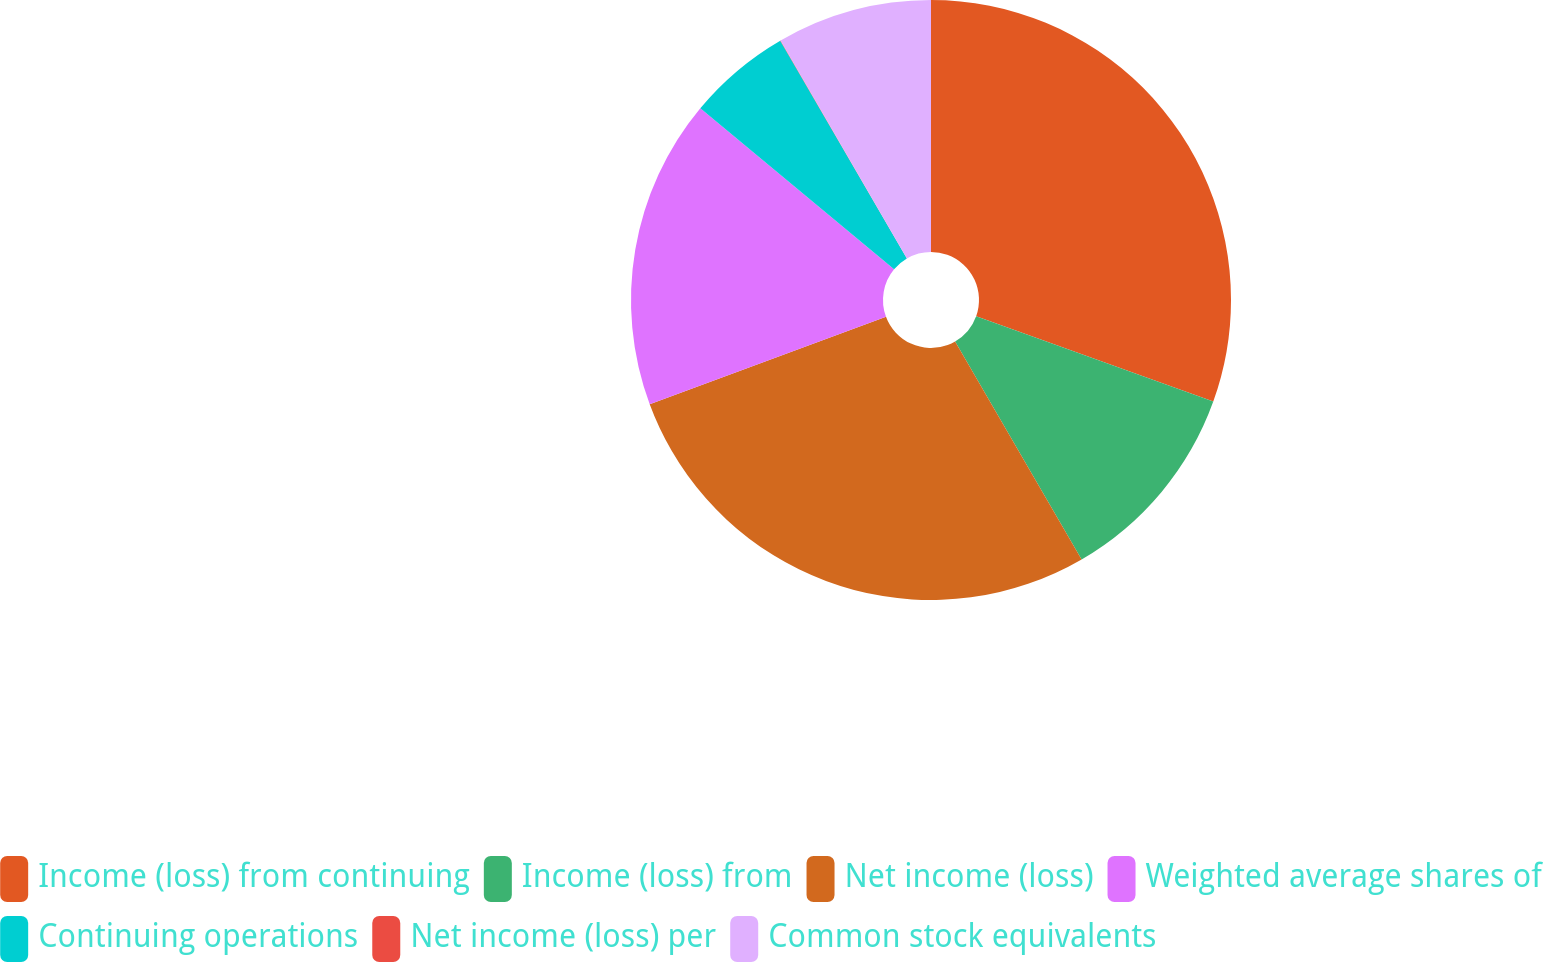<chart> <loc_0><loc_0><loc_500><loc_500><pie_chart><fcel>Income (loss) from continuing<fcel>Income (loss) from<fcel>Net income (loss)<fcel>Weighted average shares of<fcel>Continuing operations<fcel>Net income (loss) per<fcel>Common stock equivalents<nl><fcel>30.5%<fcel>11.13%<fcel>27.72%<fcel>16.69%<fcel>5.58%<fcel>0.02%<fcel>8.36%<nl></chart> 